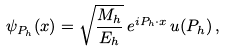<formula> <loc_0><loc_0><loc_500><loc_500>\psi _ { P _ { h } } ( x ) = \sqrt { \frac { M _ { h } } { E _ { h } } } \, e ^ { i P _ { h } \cdot x } \, u ( P _ { h } ) \, ,</formula> 